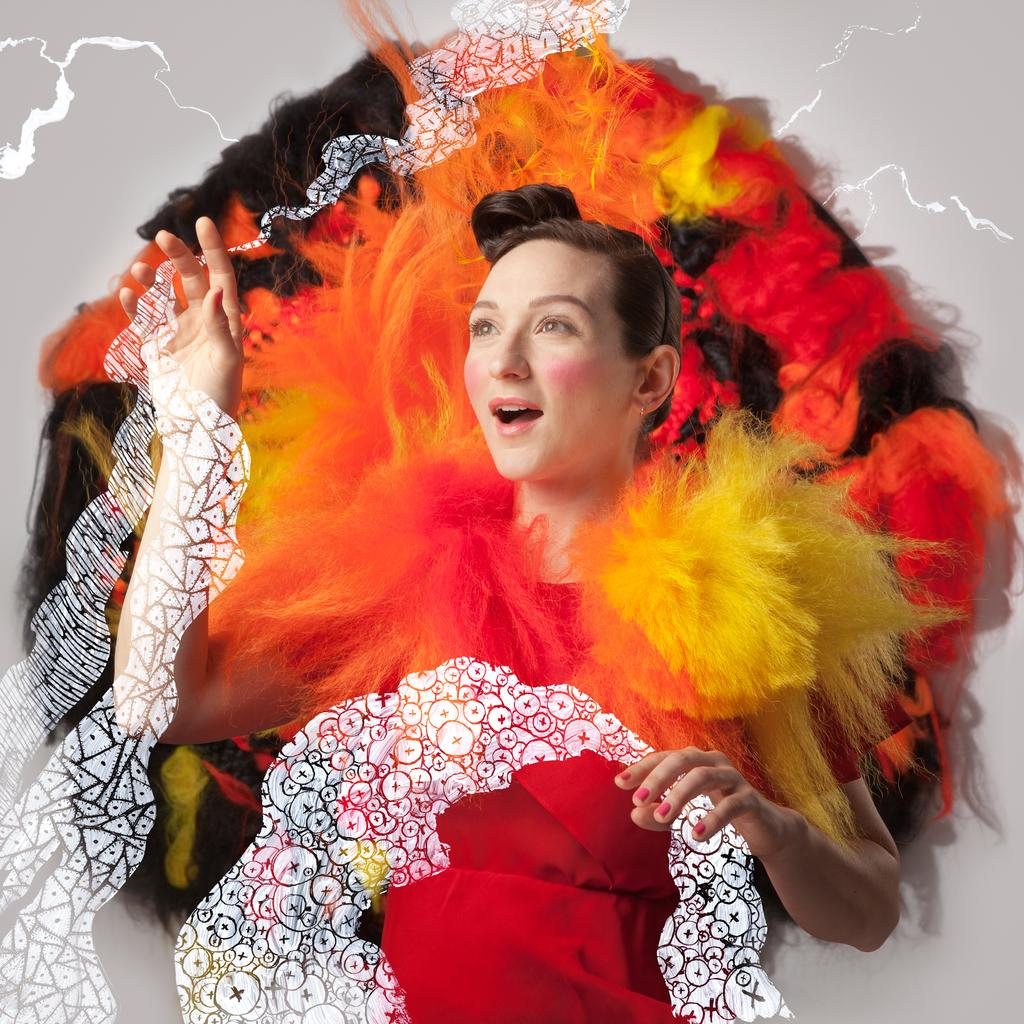Who is the main subject in the image? There is a lady in the image. What is the lady doing in the image? The lady is standing in the image. What is the lady wearing in the image? The lady is wearing a costume in the image. What type of rabbit can be seen holding a can in the image? There is no rabbit or can present in the image; it features a lady wearing a costume. How many teeth can be seen in the lady's costume in the image? The lady's costume does not have any visible teeth in the image. 